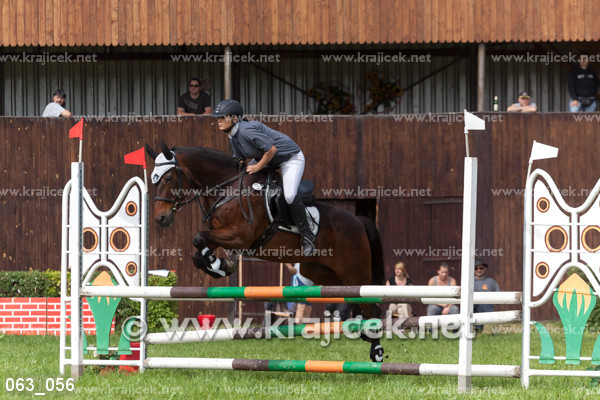Can you describe the equestrian discipline that is shown in this image? Certainly! The image depicts a show jumping event, which is a part of the equestrian sport where riders on horseback aim to jump cleanly through sets of obstacles within a specific time. The rider's skill in guiding the horse, and the horse's agility and training are both crucial for a successful round. 